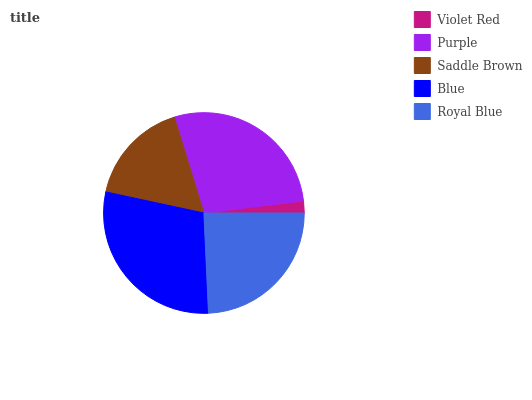Is Violet Red the minimum?
Answer yes or no. Yes. Is Blue the maximum?
Answer yes or no. Yes. Is Purple the minimum?
Answer yes or no. No. Is Purple the maximum?
Answer yes or no. No. Is Purple greater than Violet Red?
Answer yes or no. Yes. Is Violet Red less than Purple?
Answer yes or no. Yes. Is Violet Red greater than Purple?
Answer yes or no. No. Is Purple less than Violet Red?
Answer yes or no. No. Is Royal Blue the high median?
Answer yes or no. Yes. Is Royal Blue the low median?
Answer yes or no. Yes. Is Violet Red the high median?
Answer yes or no. No. Is Purple the low median?
Answer yes or no. No. 